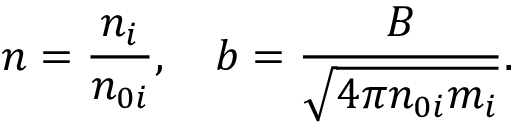Convert formula to latex. <formula><loc_0><loc_0><loc_500><loc_500>n = \frac { n _ { i } } { n _ { 0 i } } , \quad b = \frac { B } { \sqrt { 4 \pi n _ { 0 i } m _ { i } } } .</formula> 